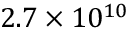<formula> <loc_0><loc_0><loc_500><loc_500>2 . 7 \times 1 0 ^ { 1 0 }</formula> 